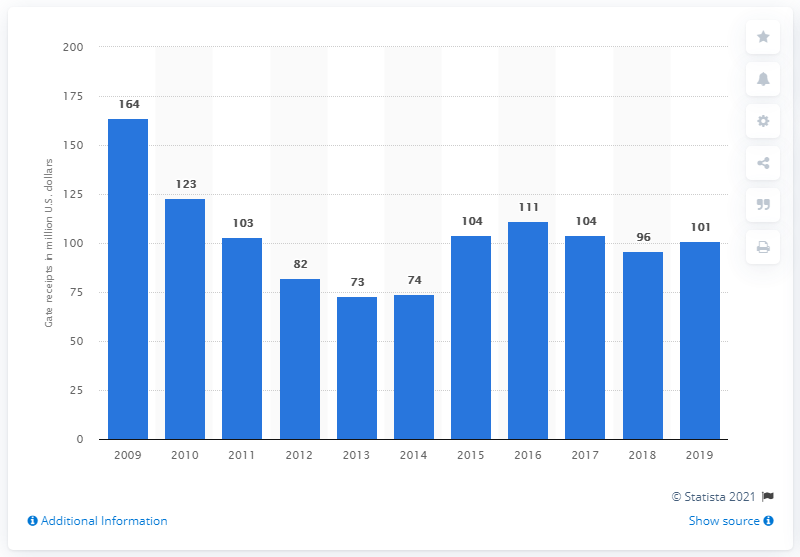Give some essential details in this illustration. The gate receipts of the New York Mets in 2019 were 101 dollars. 